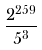<formula> <loc_0><loc_0><loc_500><loc_500>\frac { 2 ^ { 2 5 9 } } { 5 ^ { 3 } }</formula> 